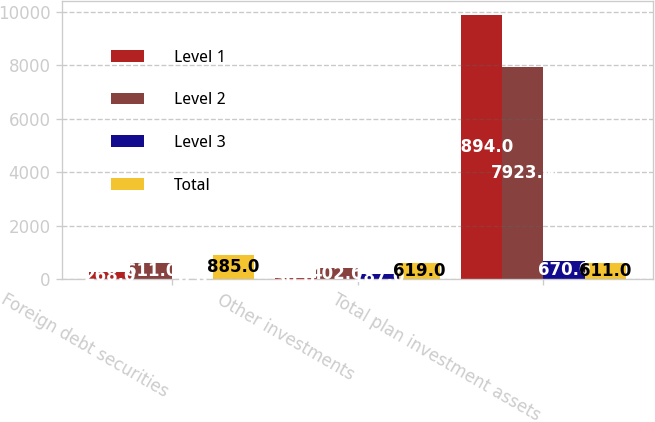Convert chart. <chart><loc_0><loc_0><loc_500><loc_500><stacked_bar_chart><ecel><fcel>Foreign debt securities<fcel>Other investments<fcel>Total plan investment assets<nl><fcel>Level 1<fcel>268<fcel>30<fcel>9894<nl><fcel>Level 2<fcel>611<fcel>402<fcel>7923<nl><fcel>Level 3<fcel>6<fcel>187<fcel>670<nl><fcel>Total<fcel>885<fcel>619<fcel>611<nl></chart> 